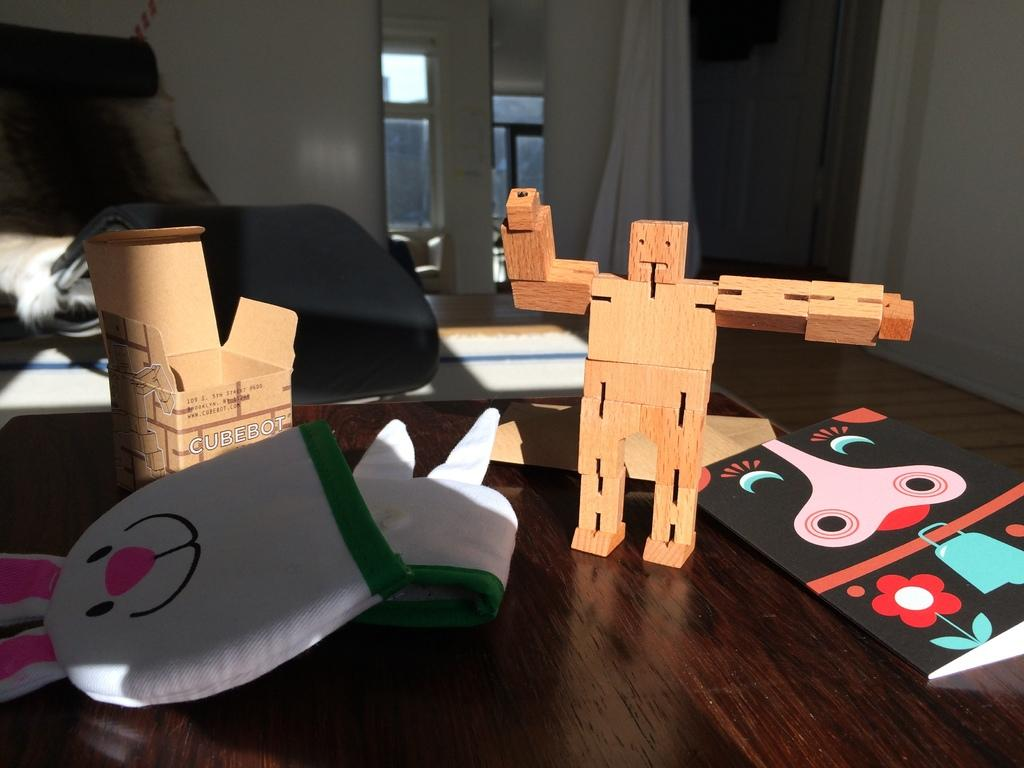<image>
Provide a brief description of the given image. A small toy robot has a box labeled Cubeot on it. 